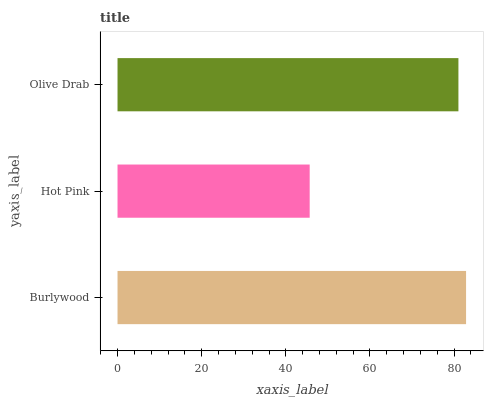Is Hot Pink the minimum?
Answer yes or no. Yes. Is Burlywood the maximum?
Answer yes or no. Yes. Is Olive Drab the minimum?
Answer yes or no. No. Is Olive Drab the maximum?
Answer yes or no. No. Is Olive Drab greater than Hot Pink?
Answer yes or no. Yes. Is Hot Pink less than Olive Drab?
Answer yes or no. Yes. Is Hot Pink greater than Olive Drab?
Answer yes or no. No. Is Olive Drab less than Hot Pink?
Answer yes or no. No. Is Olive Drab the high median?
Answer yes or no. Yes. Is Olive Drab the low median?
Answer yes or no. Yes. Is Burlywood the high median?
Answer yes or no. No. Is Burlywood the low median?
Answer yes or no. No. 